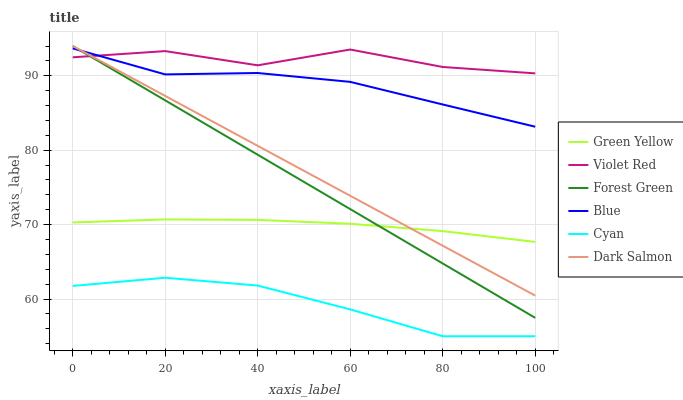Does Cyan have the minimum area under the curve?
Answer yes or no. Yes. Does Violet Red have the maximum area under the curve?
Answer yes or no. Yes. Does Dark Salmon have the minimum area under the curve?
Answer yes or no. No. Does Dark Salmon have the maximum area under the curve?
Answer yes or no. No. Is Dark Salmon the smoothest?
Answer yes or no. Yes. Is Violet Red the roughest?
Answer yes or no. Yes. Is Violet Red the smoothest?
Answer yes or no. No. Is Dark Salmon the roughest?
Answer yes or no. No. Does Cyan have the lowest value?
Answer yes or no. Yes. Does Dark Salmon have the lowest value?
Answer yes or no. No. Does Forest Green have the highest value?
Answer yes or no. Yes. Does Violet Red have the highest value?
Answer yes or no. No. Is Cyan less than Dark Salmon?
Answer yes or no. Yes. Is Forest Green greater than Cyan?
Answer yes or no. Yes. Does Dark Salmon intersect Green Yellow?
Answer yes or no. Yes. Is Dark Salmon less than Green Yellow?
Answer yes or no. No. Is Dark Salmon greater than Green Yellow?
Answer yes or no. No. Does Cyan intersect Dark Salmon?
Answer yes or no. No. 